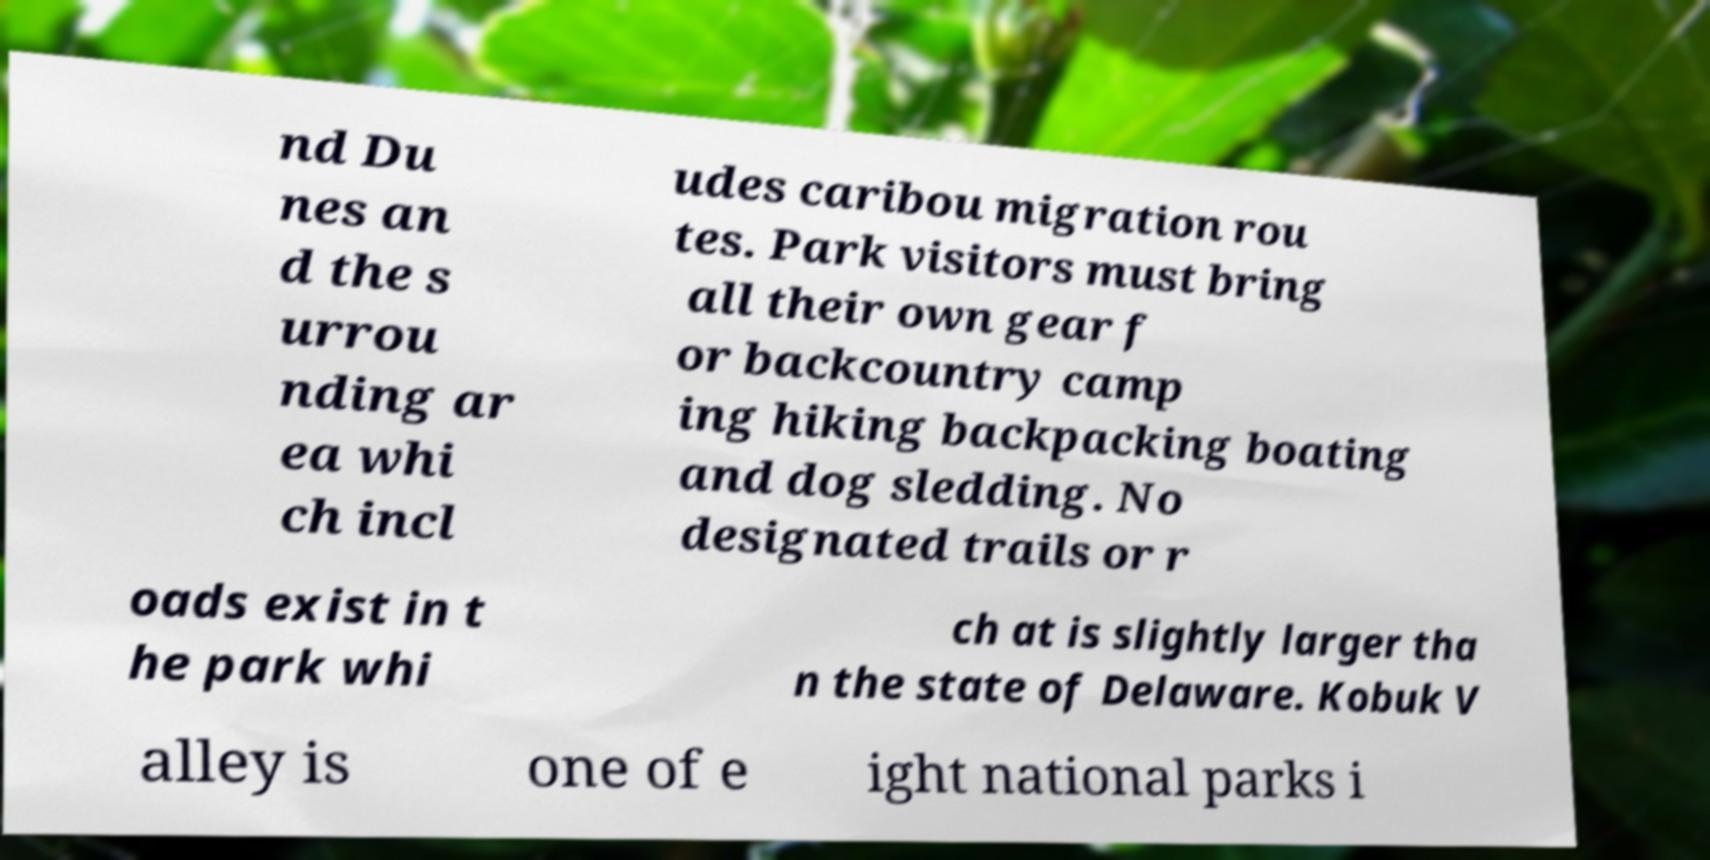For documentation purposes, I need the text within this image transcribed. Could you provide that? nd Du nes an d the s urrou nding ar ea whi ch incl udes caribou migration rou tes. Park visitors must bring all their own gear f or backcountry camp ing hiking backpacking boating and dog sledding. No designated trails or r oads exist in t he park whi ch at is slightly larger tha n the state of Delaware. Kobuk V alley is one of e ight national parks i 